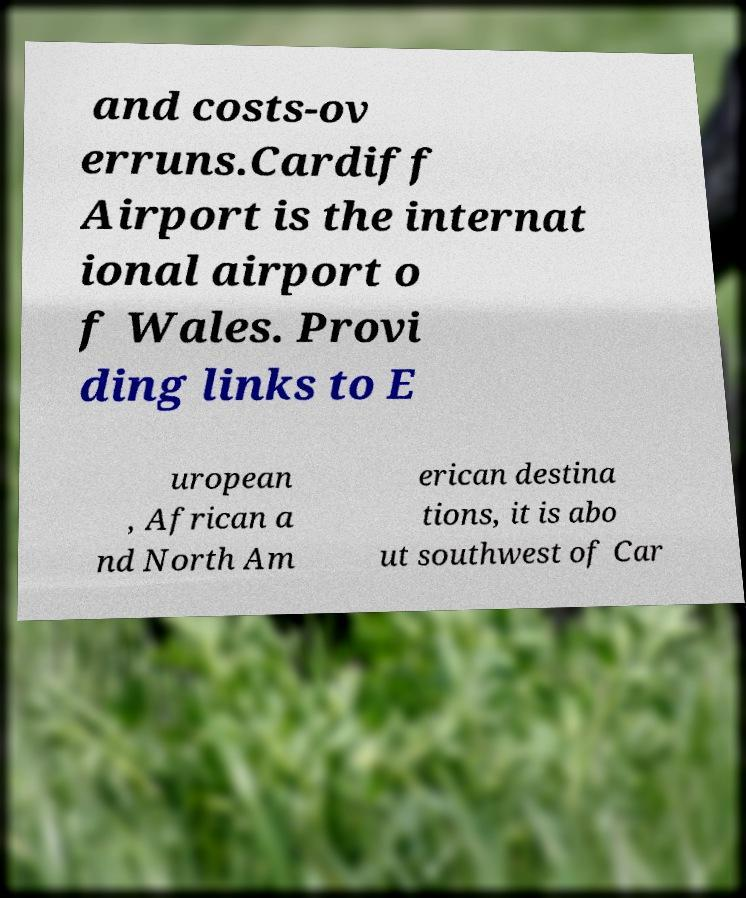For documentation purposes, I need the text within this image transcribed. Could you provide that? and costs-ov erruns.Cardiff Airport is the internat ional airport o f Wales. Provi ding links to E uropean , African a nd North Am erican destina tions, it is abo ut southwest of Car 